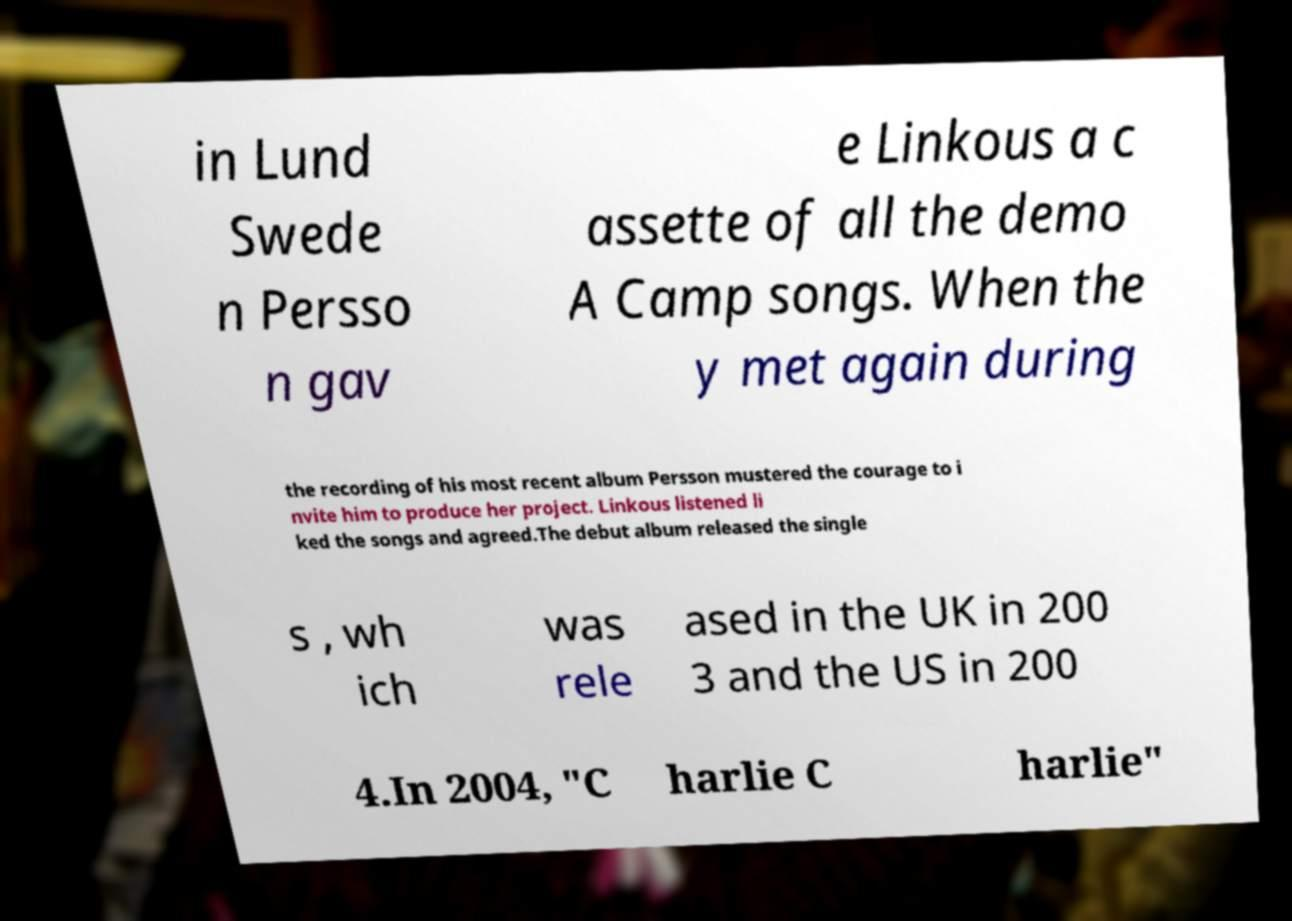Please read and relay the text visible in this image. What does it say? in Lund Swede n Persso n gav e Linkous a c assette of all the demo A Camp songs. When the y met again during the recording of his most recent album Persson mustered the courage to i nvite him to produce her project. Linkous listened li ked the songs and agreed.The debut album released the single s , wh ich was rele ased in the UK in 200 3 and the US in 200 4.In 2004, "C harlie C harlie" 